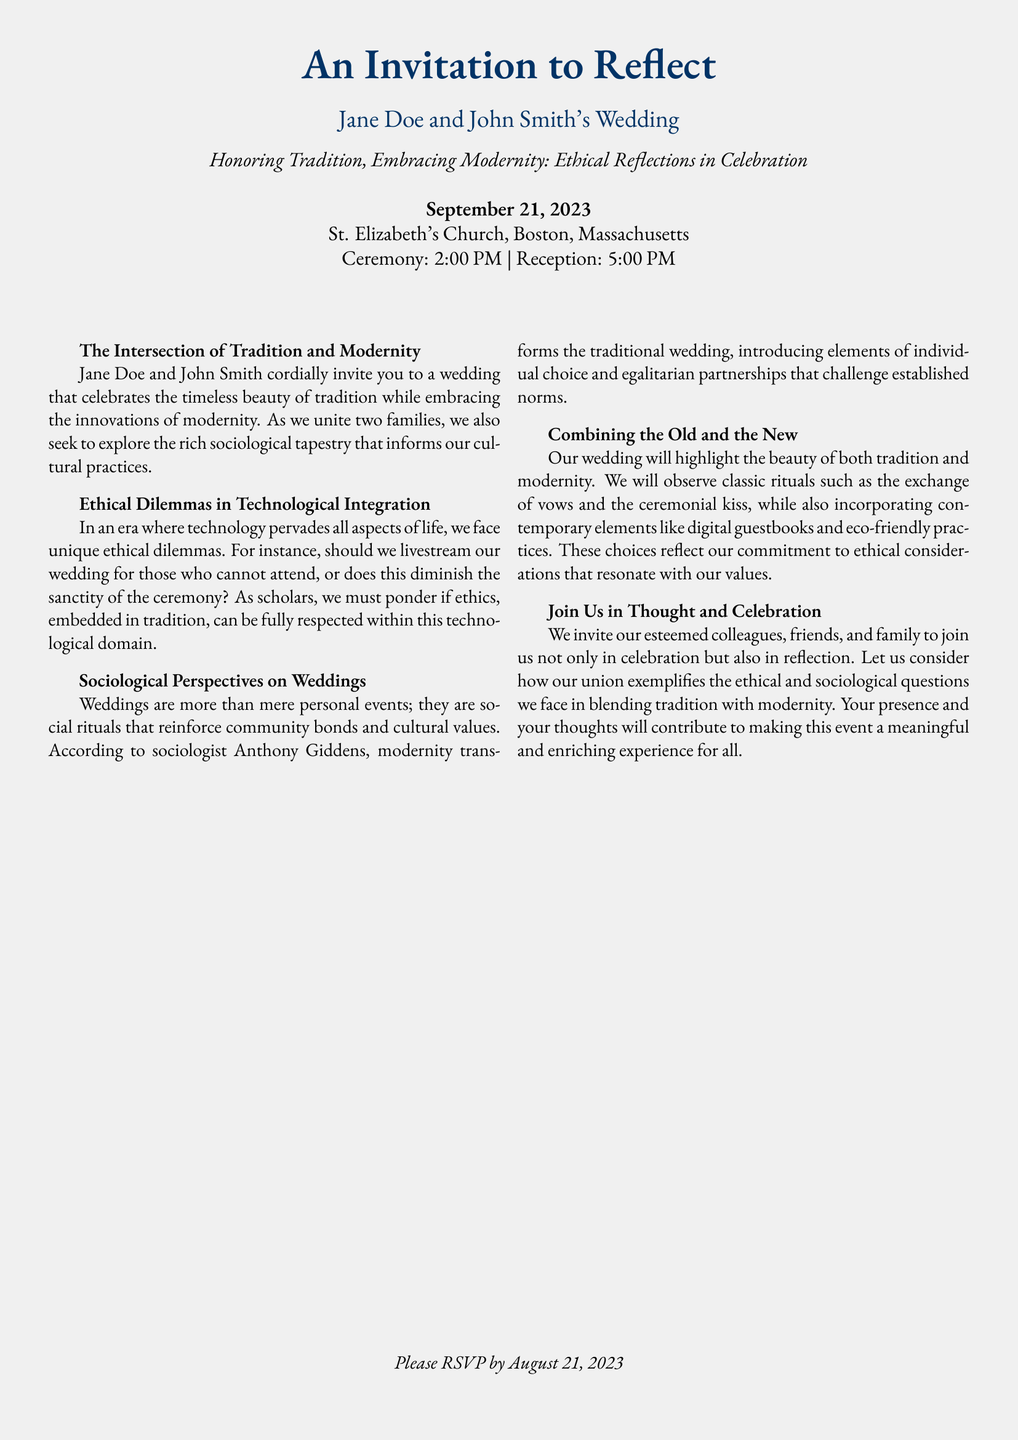What is the date of the wedding? The date is explicitly written in the invitation as September 21, 2023.
Answer: September 21, 2023 What is the location of the reception? The reception is held at St. Elizabeth's Church, which is stated in the document.
Answer: St. Elizabeth's Church What time does the ceremony start? The invitation specifies that the ceremony starts at 2:00 PM.
Answer: 2:00 PM What ethical dilemma is mentioned regarding technology? The document discusses whether to livestream the wedding, as it may affect the ceremony's sanctity.
Answer: Livestreaming Which sociologist's perspective is referenced? The invitation mentions sociologist Anthony Giddens when discussing weddings and modernity.
Answer: Anthony Giddens What are guests invited to consider during the event? Guests are invited to reflect on the ethical and sociological questions about blending tradition and modernity.
Answer: Ethical and sociological questions What is one modern element incorporated into the wedding? The document states that the couple will have a digital guestbook, which is a modern element.
Answer: Digital guestbook What should guests do by August 21, 2023? The invitation requests that guests RSVP by this date, which is mentioned in the document.
Answer: RSVP 